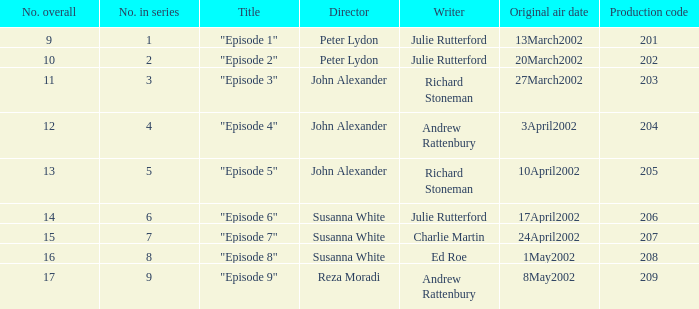When 1 is the figure in sequence, who is the filmmaker? Peter Lydon. 